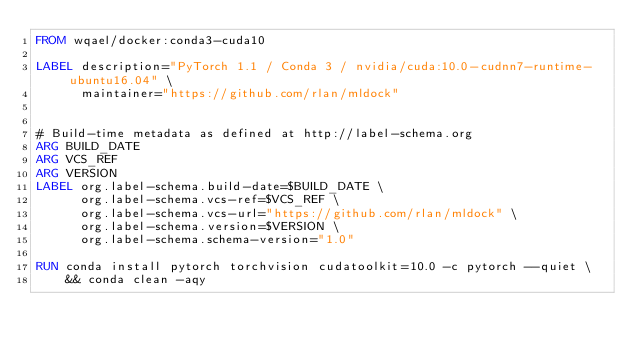<code> <loc_0><loc_0><loc_500><loc_500><_Dockerfile_>FROM wqael/docker:conda3-cuda10

LABEL description="PyTorch 1.1 / Conda 3 / nvidia/cuda:10.0-cudnn7-runtime-ubuntu16.04" \
      maintainer="https://github.com/rlan/mldock"


# Build-time metadata as defined at http://label-schema.org
ARG BUILD_DATE
ARG VCS_REF
ARG VERSION
LABEL org.label-schema.build-date=$BUILD_DATE \
      org.label-schema.vcs-ref=$VCS_REF \
      org.label-schema.vcs-url="https://github.com/rlan/mldock" \
      org.label-schema.version=$VERSION \
      org.label-schema.schema-version="1.0"

RUN conda install pytorch torchvision cudatoolkit=10.0 -c pytorch --quiet \
    && conda clean -aqy
</code> 